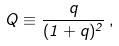<formula> <loc_0><loc_0><loc_500><loc_500>Q \equiv \frac { q } { ( 1 + q ) ^ { 2 } } \, ,</formula> 